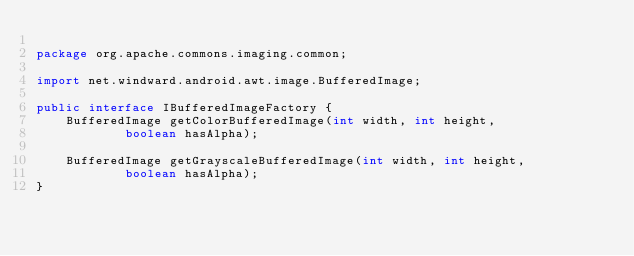Convert code to text. <code><loc_0><loc_0><loc_500><loc_500><_Java_>
package org.apache.commons.imaging.common;

import net.windward.android.awt.image.BufferedImage;

public interface IBufferedImageFactory {
    BufferedImage getColorBufferedImage(int width, int height,
            boolean hasAlpha);

    BufferedImage getGrayscaleBufferedImage(int width, int height,
            boolean hasAlpha);
}
</code> 